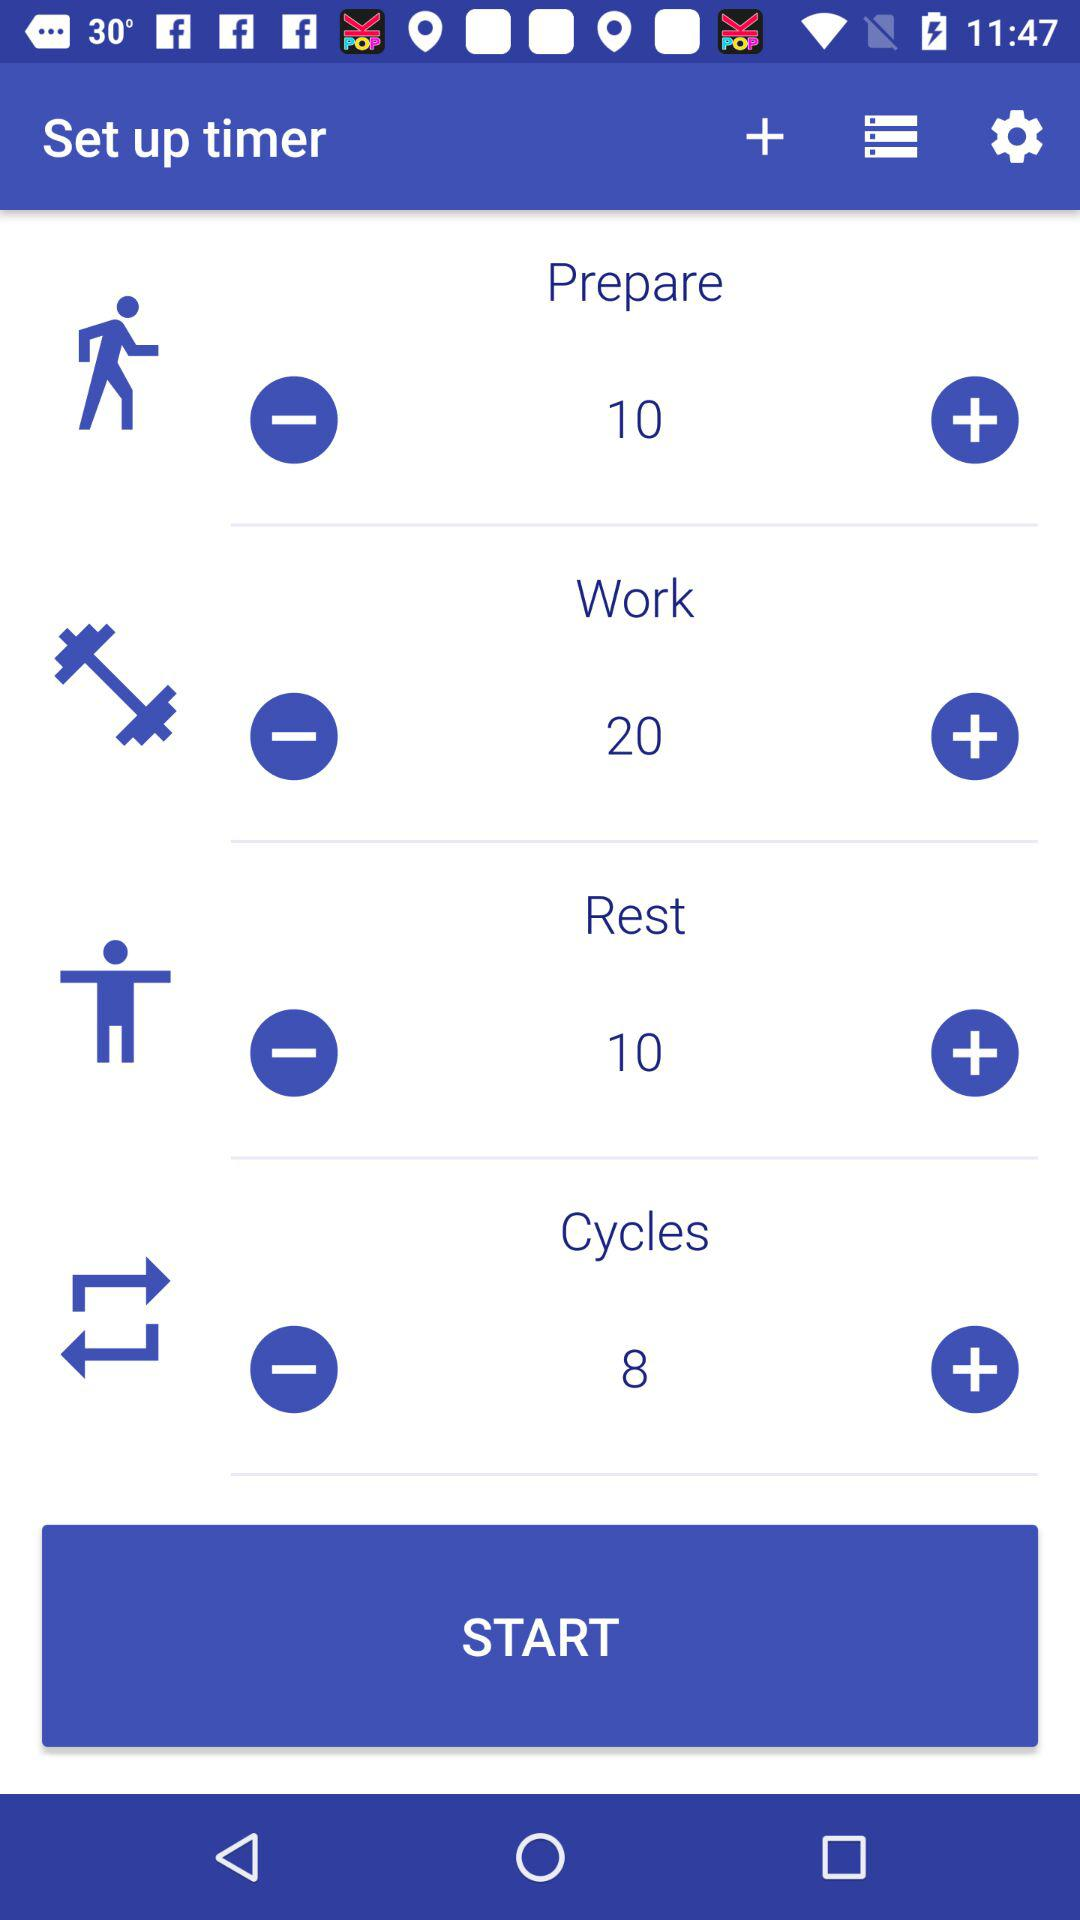How many fewer cycles than rest does the refresh phase have?
Answer the question using a single word or phrase. 2 